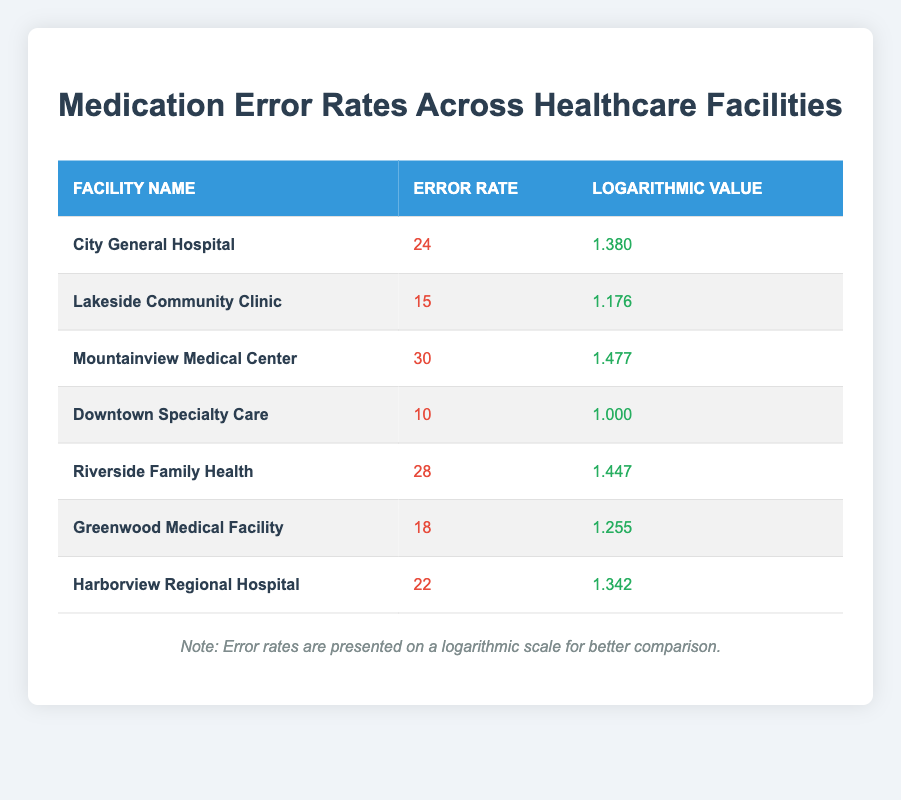What is the medication error rate for City General Hospital? The table lists the error rate for City General Hospital as 24, which is directly shown in the second column.
Answer: 24 Which facility has the lowest error rate? By examining the error rates listed in the table, Downtown Specialty Care has the lowest error rate at 10.
Answer: Downtown Specialty Care What is the logarithmic value for Riverside Family Health? The table provides the logarithmic value for Riverside Family Health as 1.447, directly found in the third column next to the facility's name.
Answer: 1.447 What is the average medication error rate across all facilities? To calculate the average, sum the error rates (24 + 15 + 30 + 10 + 28 + 18 + 22) = 147. Since there are 7 facilities, the average is 147 divided by 7, which equals 21.
Answer: 21 Is the error rate for Mountainview Medical Center greater than that for Harborview Regional Hospital? Mountainview Medical Center has an error rate of 30, while Harborview Regional Hospital has an error rate of 22. Since 30 is greater than 22, the statement is true.
Answer: Yes Which facility has the highest logarithmic value, and what is that value? By reviewing the logarithmic values in the table, Mountainview Medical Center has the highest value at 1.477 listed in the third column.
Answer: Mountainview Medical Center, 1.477 What is the difference in error rates between City General Hospital and Lakeside Community Clinic? City General Hospital has an error rate of 24, and Lakeside Community Clinic has an error rate of 15. To find the difference, subtract 15 from 24, which is 9.
Answer: 9 Are there any facilities with logarithmic values over 1.4? Looking at the logarithmic values, both Mountainview Medical Center (1.477) and Riverside Family Health (1.447) exceed 1.4, confirming that the statement is true.
Answer: Yes What is the sum of error rates for facilities with a logarithmic value below 1.3? The facilities with logarithmic values below 1.3 are Downtown Specialty Care (error rate 10) and Lakeside Community Clinic (error rate 15). The sum is 10 + 15 = 25.
Answer: 25 